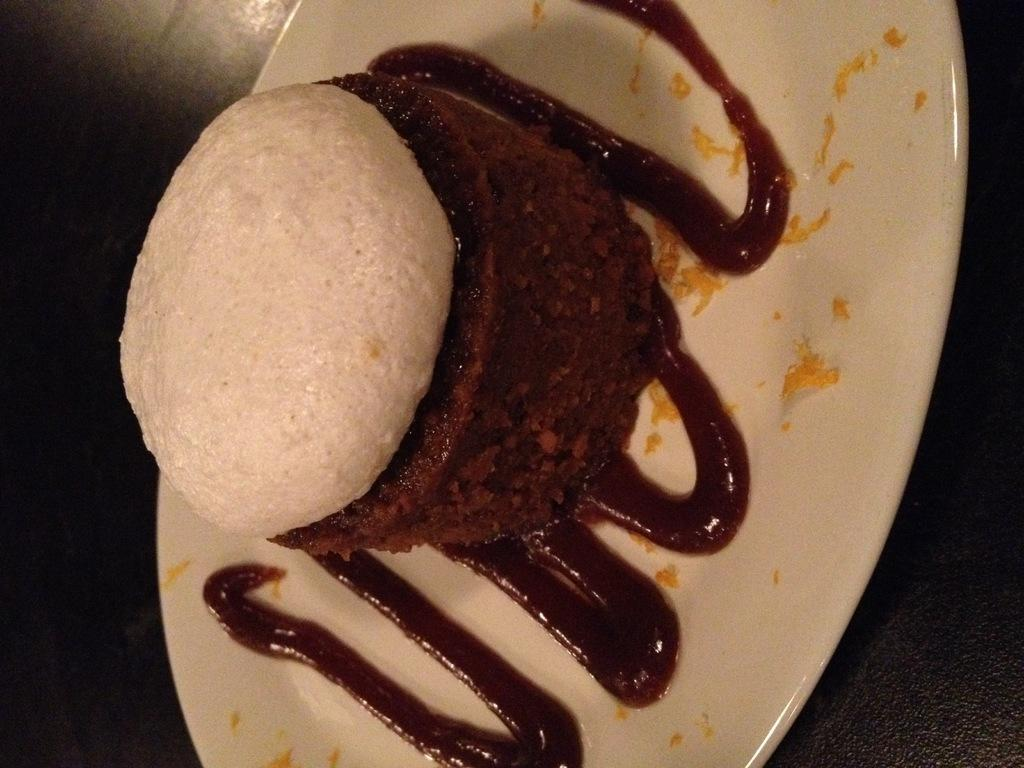What object is present on the plate in the image? There is a food item on the plate in the image. Can you describe the appearance of the food item? The food item has brown and white colors. What else is present on the plate besides the food item? There is sauce on the plate. Can you see any feathers on the food item in the image? There are no feathers present on the food item in the image. Is there a giraffe visible in the image? There is no giraffe present in the image. 